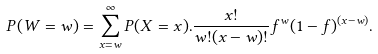<formula> <loc_0><loc_0><loc_500><loc_500>P ( W = w ) = \sum _ { x = w } ^ { \infty } P ( X = x ) . \frac { x ! } { w ! ( x - w ) ! } f ^ { w } ( 1 - f ) ^ { ( x - w ) } .</formula> 